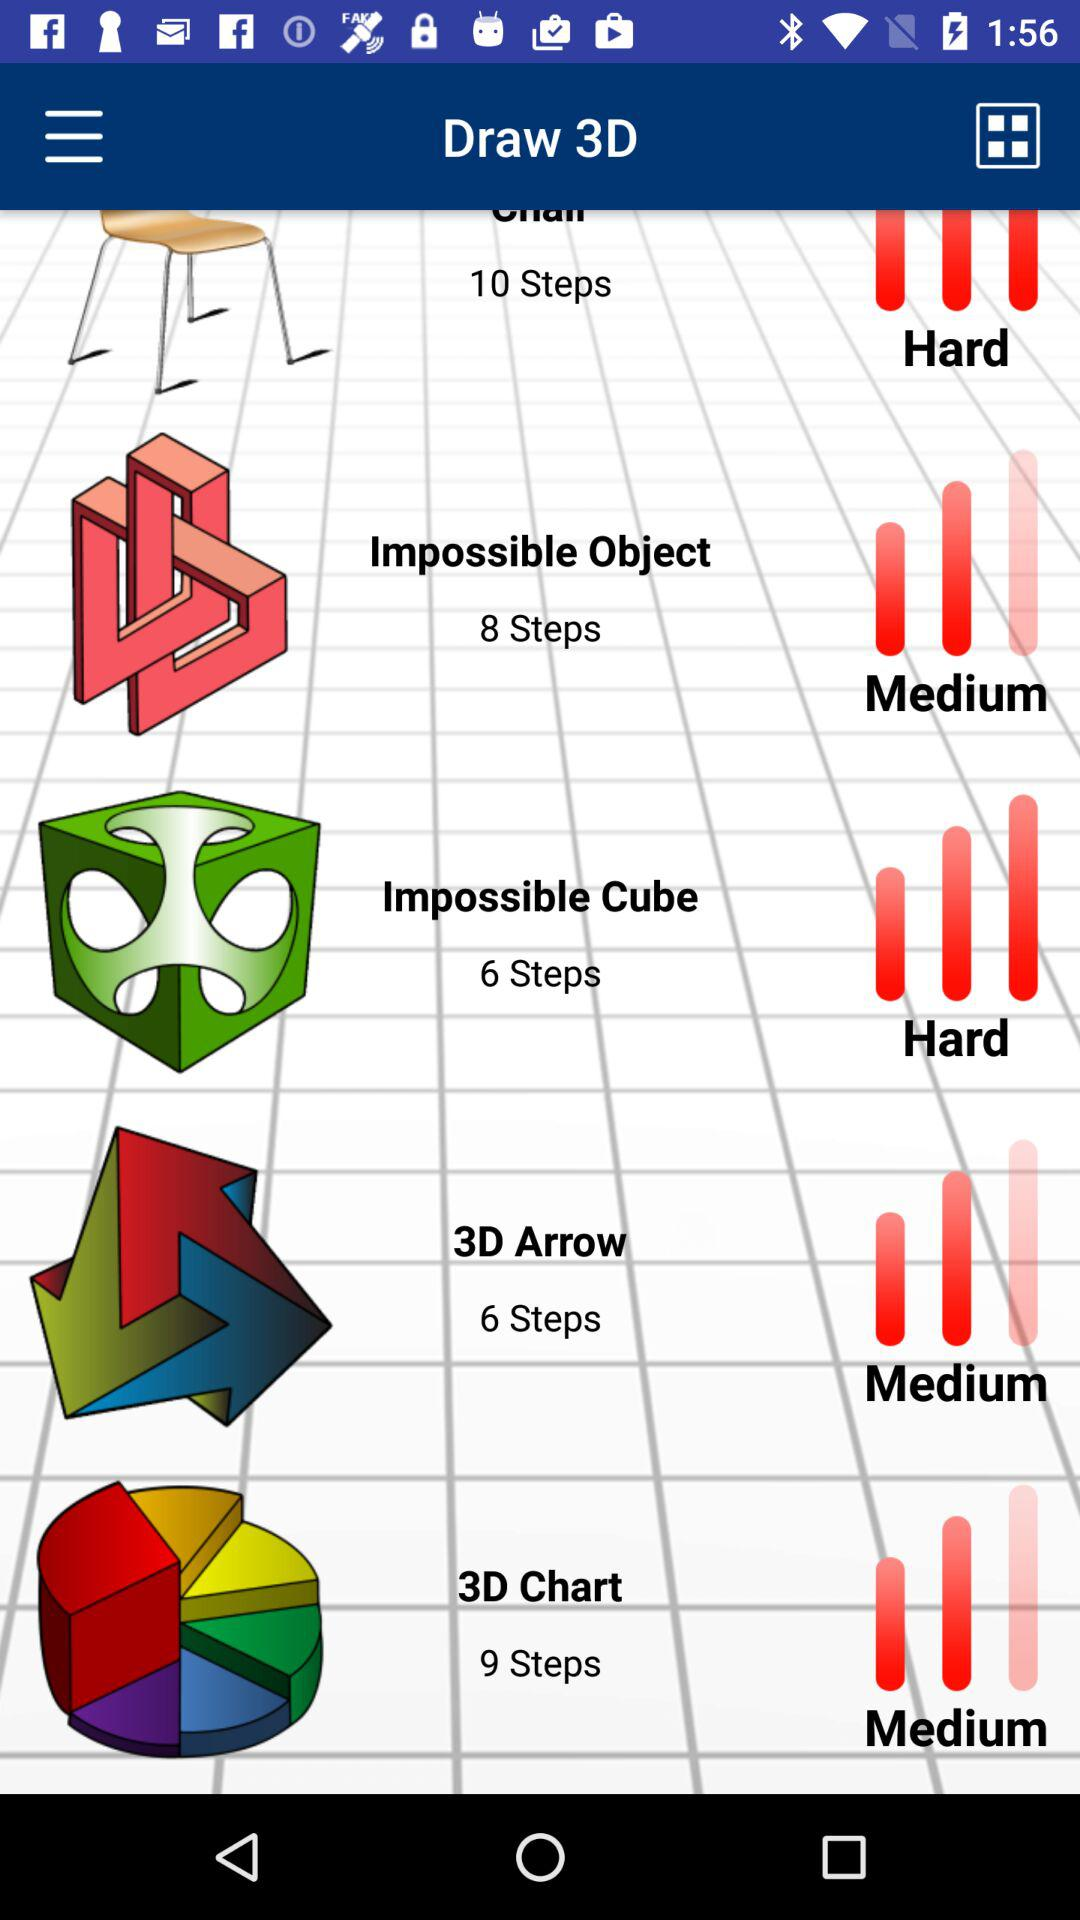How many steps are there in the hardest project?
Answer the question using a single word or phrase. 10 